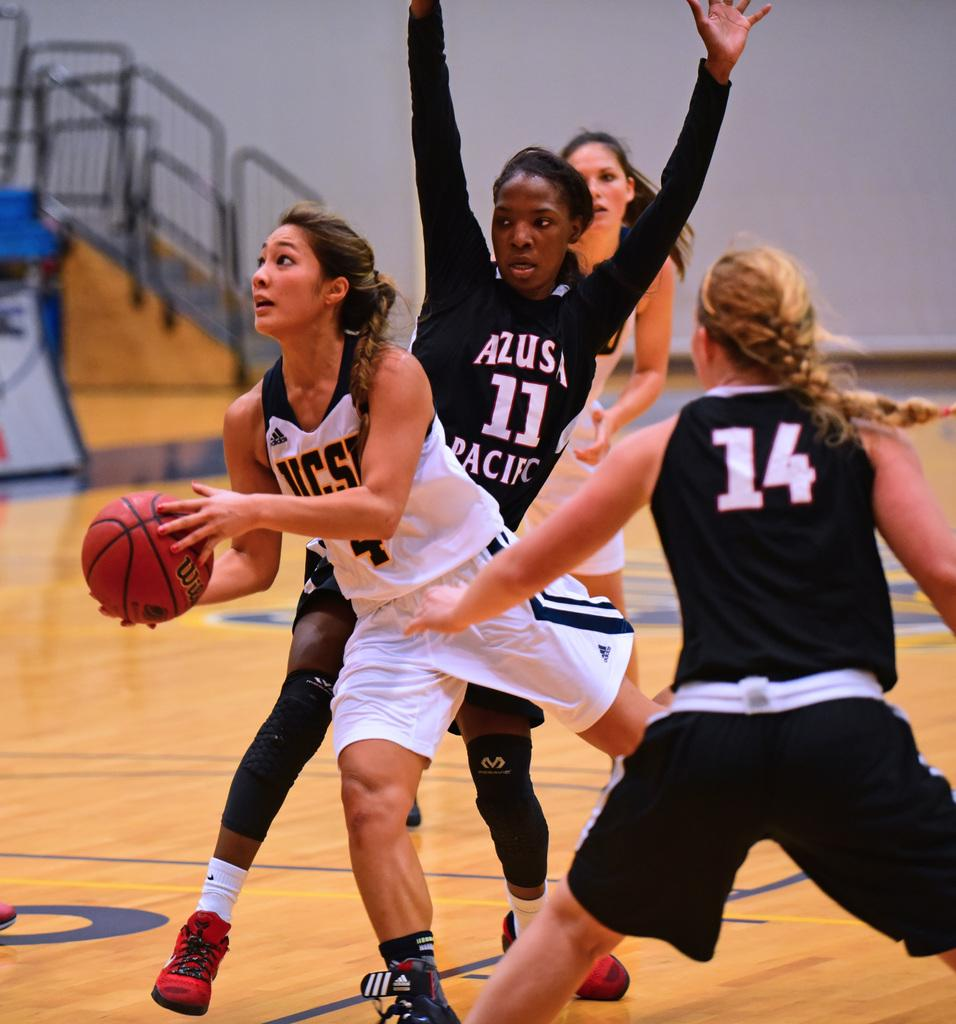Provide a one-sentence caption for the provided image. A girls basketball game with numbers 14 and 11 playing on the same team. 